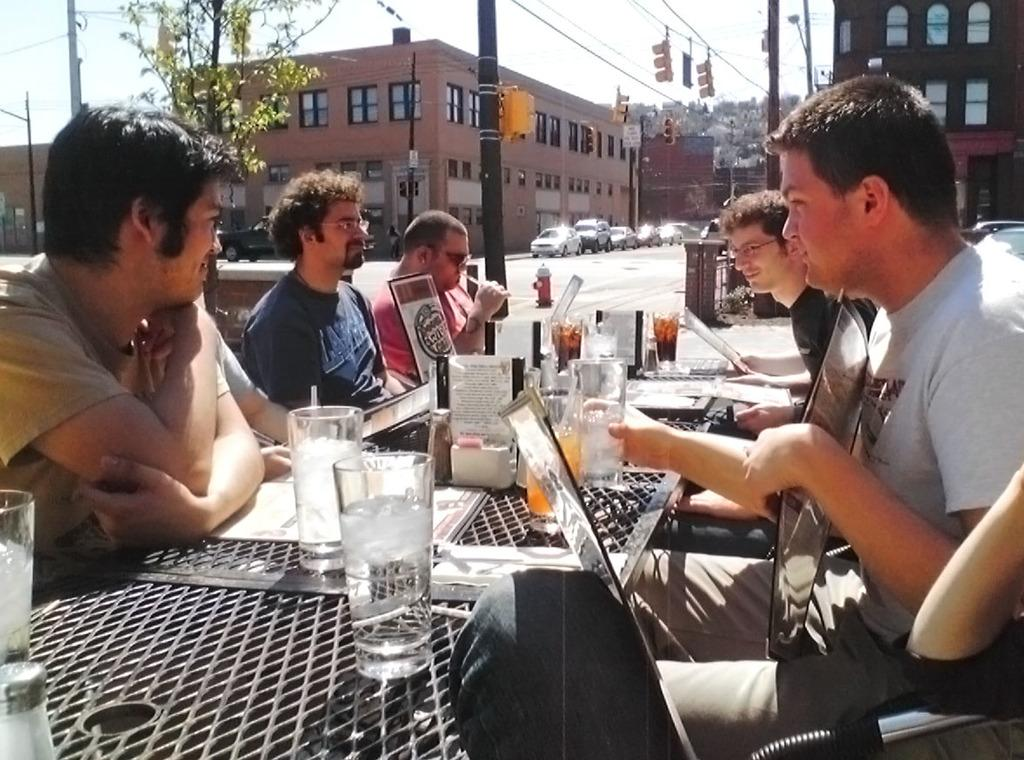How many people are sitting on chairs in the image? There are five people sitting on chairs in the image. What is on the table in the image? There is a glass and a stand on the table in the image. What can be seen in the background of the image? There is a building and cars visible in the background. What type of cream is being used to express anger in the image? There is no cream or expression of anger present in the image. 